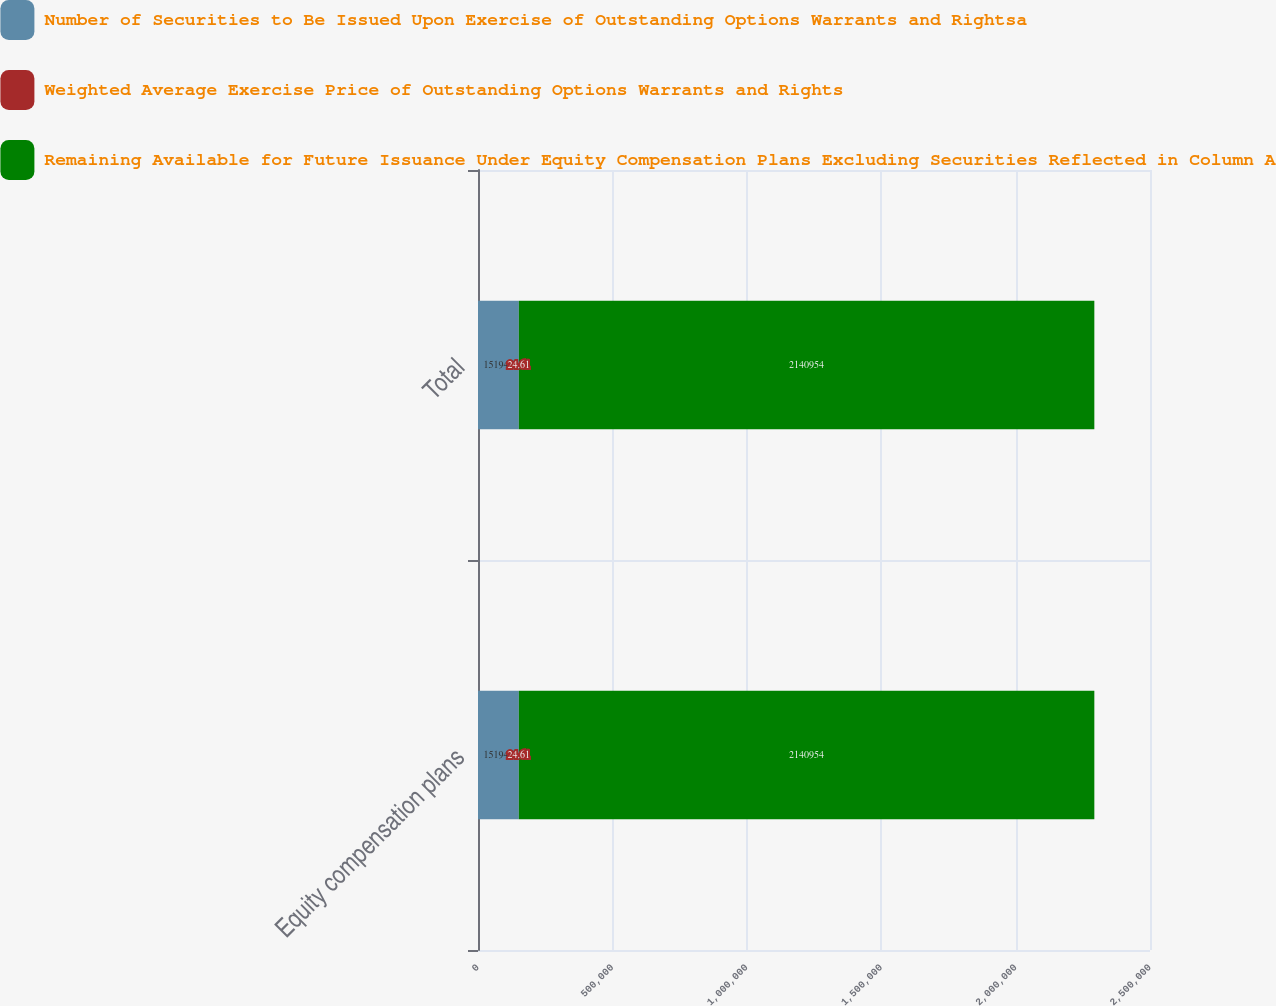Convert chart to OTSL. <chart><loc_0><loc_0><loc_500><loc_500><stacked_bar_chart><ecel><fcel>Equity compensation plans<fcel>Total<nl><fcel>Number of Securities to Be Issued Upon Exercise of Outstanding Options Warrants and Rightsa<fcel>151945<fcel>151945<nl><fcel>Weighted Average Exercise Price of Outstanding Options Warrants and Rights<fcel>24.61<fcel>24.61<nl><fcel>Remaining Available for Future Issuance Under Equity Compensation Plans Excluding Securities Reflected in Column A<fcel>2.14095e+06<fcel>2.14095e+06<nl></chart> 